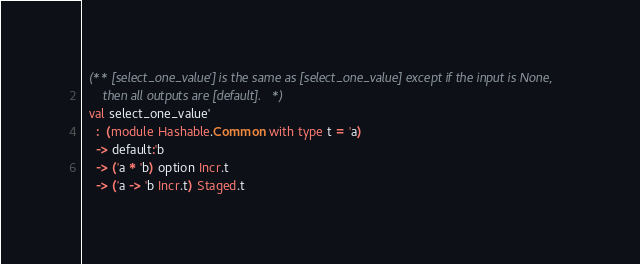<code> <loc_0><loc_0><loc_500><loc_500><_OCaml_>  (** [select_one_value'] is the same as [select_one_value] except if the input is None,
      then all outputs are [default]. *)
  val select_one_value'
    :  (module Hashable.Common with type t = 'a)
    -> default:'b
    -> ('a * 'b) option Incr.t
    -> ('a -> 'b Incr.t) Staged.t
</code> 